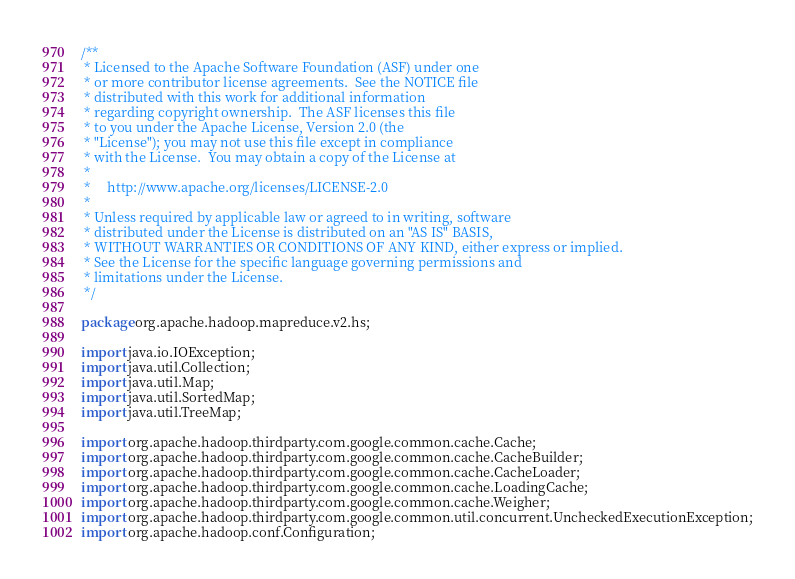Convert code to text. <code><loc_0><loc_0><loc_500><loc_500><_Java_>/**
 * Licensed to the Apache Software Foundation (ASF) under one
 * or more contributor license agreements.  See the NOTICE file
 * distributed with this work for additional information
 * regarding copyright ownership.  The ASF licenses this file
 * to you under the Apache License, Version 2.0 (the
 * "License"); you may not use this file except in compliance
 * with the License.  You may obtain a copy of the License at
 *
 *     http://www.apache.org/licenses/LICENSE-2.0
 *
 * Unless required by applicable law or agreed to in writing, software
 * distributed under the License is distributed on an "AS IS" BASIS,
 * WITHOUT WARRANTIES OR CONDITIONS OF ANY KIND, either express or implied.
 * See the License for the specific language governing permissions and
 * limitations under the License.
 */

package org.apache.hadoop.mapreduce.v2.hs;

import java.io.IOException;
import java.util.Collection;
import java.util.Map;
import java.util.SortedMap;
import java.util.TreeMap;

import org.apache.hadoop.thirdparty.com.google.common.cache.Cache;
import org.apache.hadoop.thirdparty.com.google.common.cache.CacheBuilder;
import org.apache.hadoop.thirdparty.com.google.common.cache.CacheLoader;
import org.apache.hadoop.thirdparty.com.google.common.cache.LoadingCache;
import org.apache.hadoop.thirdparty.com.google.common.cache.Weigher;
import org.apache.hadoop.thirdparty.com.google.common.util.concurrent.UncheckedExecutionException;
import org.apache.hadoop.conf.Configuration;</code> 